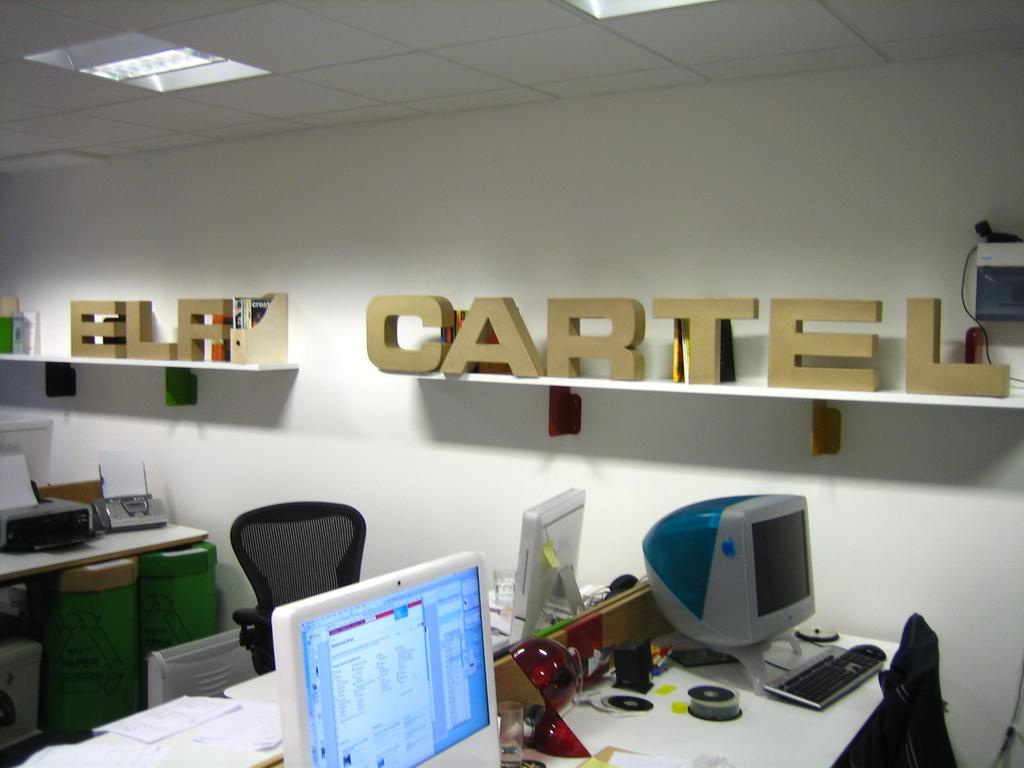<image>
Summarize the visual content of the image. the word cartel is above the computers in the office 